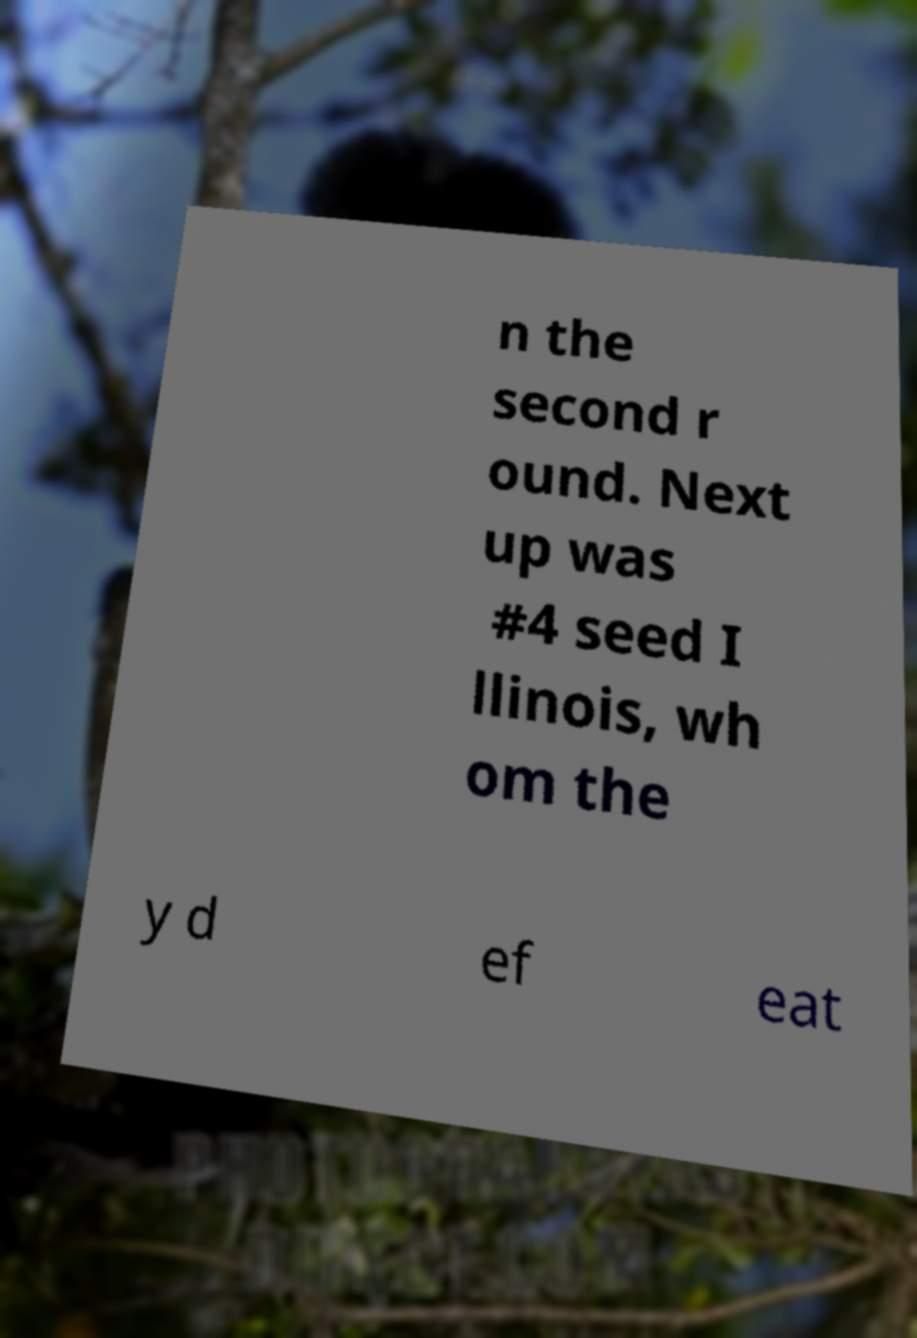Could you extract and type out the text from this image? n the second r ound. Next up was #4 seed I llinois, wh om the y d ef eat 